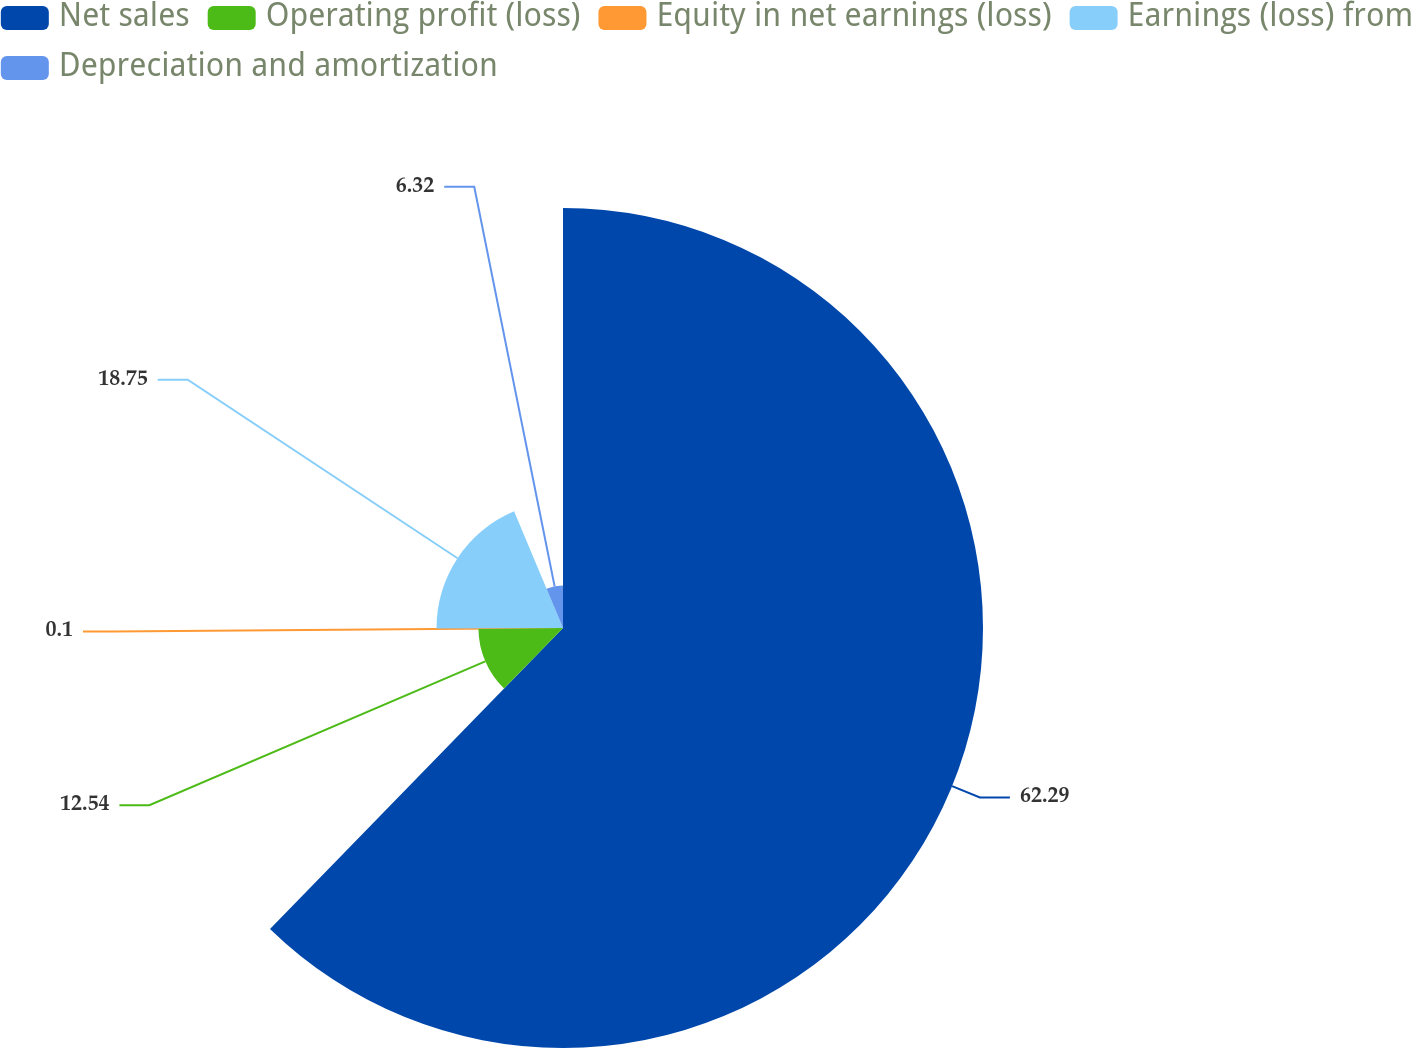Convert chart. <chart><loc_0><loc_0><loc_500><loc_500><pie_chart><fcel>Net sales<fcel>Operating profit (loss)<fcel>Equity in net earnings (loss)<fcel>Earnings (loss) from<fcel>Depreciation and amortization<nl><fcel>62.3%<fcel>12.54%<fcel>0.1%<fcel>18.76%<fcel>6.32%<nl></chart> 